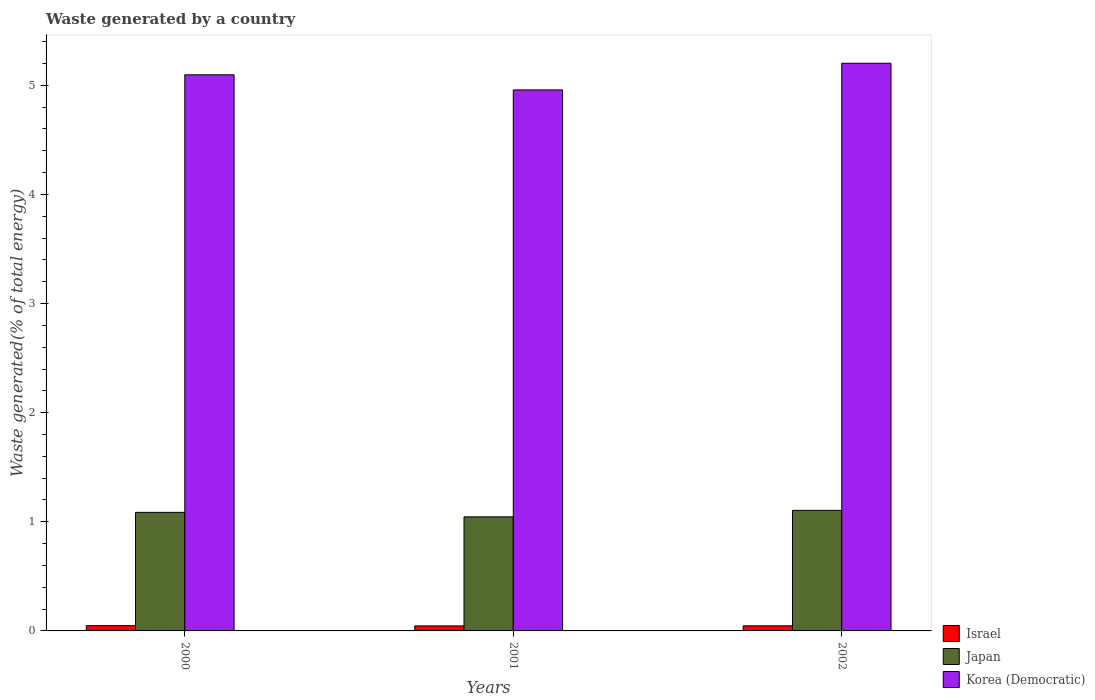How many different coloured bars are there?
Your answer should be very brief. 3. Are the number of bars per tick equal to the number of legend labels?
Keep it short and to the point. Yes. How many bars are there on the 1st tick from the left?
Your answer should be very brief. 3. What is the label of the 1st group of bars from the left?
Offer a very short reply. 2000. In how many cases, is the number of bars for a given year not equal to the number of legend labels?
Your answer should be compact. 0. What is the total waste generated in Israel in 2001?
Provide a short and direct response. 0.05. Across all years, what is the maximum total waste generated in Japan?
Give a very brief answer. 1.1. Across all years, what is the minimum total waste generated in Israel?
Keep it short and to the point. 0.05. In which year was the total waste generated in Israel maximum?
Ensure brevity in your answer.  2000. In which year was the total waste generated in Korea (Democratic) minimum?
Give a very brief answer. 2001. What is the total total waste generated in Korea (Democratic) in the graph?
Keep it short and to the point. 15.26. What is the difference between the total waste generated in Israel in 2001 and that in 2002?
Offer a very short reply. -0. What is the difference between the total waste generated in Japan in 2000 and the total waste generated in Korea (Democratic) in 2001?
Offer a terse response. -3.87. What is the average total waste generated in Korea (Democratic) per year?
Ensure brevity in your answer.  5.09. In the year 2000, what is the difference between the total waste generated in Japan and total waste generated in Israel?
Keep it short and to the point. 1.04. What is the ratio of the total waste generated in Korea (Democratic) in 2001 to that in 2002?
Provide a short and direct response. 0.95. Is the total waste generated in Israel in 2001 less than that in 2002?
Your response must be concise. Yes. Is the difference between the total waste generated in Japan in 2000 and 2001 greater than the difference between the total waste generated in Israel in 2000 and 2001?
Keep it short and to the point. Yes. What is the difference between the highest and the second highest total waste generated in Japan?
Make the answer very short. 0.02. What is the difference between the highest and the lowest total waste generated in Israel?
Your response must be concise. 0. In how many years, is the total waste generated in Japan greater than the average total waste generated in Japan taken over all years?
Offer a terse response. 2. Is the sum of the total waste generated in Korea (Democratic) in 2000 and 2001 greater than the maximum total waste generated in Japan across all years?
Make the answer very short. Yes. What does the 1st bar from the right in 2000 represents?
Your response must be concise. Korea (Democratic). Where does the legend appear in the graph?
Give a very brief answer. Bottom right. How are the legend labels stacked?
Make the answer very short. Vertical. What is the title of the graph?
Offer a terse response. Waste generated by a country. Does "Ireland" appear as one of the legend labels in the graph?
Keep it short and to the point. No. What is the label or title of the X-axis?
Keep it short and to the point. Years. What is the label or title of the Y-axis?
Make the answer very short. Waste generated(% of total energy). What is the Waste generated(% of total energy) in Israel in 2000?
Ensure brevity in your answer.  0.05. What is the Waste generated(% of total energy) in Japan in 2000?
Give a very brief answer. 1.09. What is the Waste generated(% of total energy) in Korea (Democratic) in 2000?
Provide a succinct answer. 5.1. What is the Waste generated(% of total energy) in Israel in 2001?
Provide a short and direct response. 0.05. What is the Waste generated(% of total energy) of Japan in 2001?
Give a very brief answer. 1.05. What is the Waste generated(% of total energy) in Korea (Democratic) in 2001?
Offer a terse response. 4.96. What is the Waste generated(% of total energy) of Israel in 2002?
Keep it short and to the point. 0.05. What is the Waste generated(% of total energy) of Japan in 2002?
Ensure brevity in your answer.  1.1. What is the Waste generated(% of total energy) in Korea (Democratic) in 2002?
Keep it short and to the point. 5.2. Across all years, what is the maximum Waste generated(% of total energy) in Israel?
Offer a terse response. 0.05. Across all years, what is the maximum Waste generated(% of total energy) of Japan?
Ensure brevity in your answer.  1.1. Across all years, what is the maximum Waste generated(% of total energy) of Korea (Democratic)?
Make the answer very short. 5.2. Across all years, what is the minimum Waste generated(% of total energy) of Israel?
Your answer should be compact. 0.05. Across all years, what is the minimum Waste generated(% of total energy) in Japan?
Your answer should be compact. 1.05. Across all years, what is the minimum Waste generated(% of total energy) in Korea (Democratic)?
Your answer should be very brief. 4.96. What is the total Waste generated(% of total energy) of Israel in the graph?
Provide a succinct answer. 0.14. What is the total Waste generated(% of total energy) of Japan in the graph?
Your answer should be very brief. 3.24. What is the total Waste generated(% of total energy) of Korea (Democratic) in the graph?
Your answer should be very brief. 15.26. What is the difference between the Waste generated(% of total energy) of Israel in 2000 and that in 2001?
Keep it short and to the point. 0. What is the difference between the Waste generated(% of total energy) in Japan in 2000 and that in 2001?
Provide a succinct answer. 0.04. What is the difference between the Waste generated(% of total energy) in Korea (Democratic) in 2000 and that in 2001?
Your response must be concise. 0.14. What is the difference between the Waste generated(% of total energy) of Israel in 2000 and that in 2002?
Your response must be concise. 0. What is the difference between the Waste generated(% of total energy) in Japan in 2000 and that in 2002?
Offer a very short reply. -0.02. What is the difference between the Waste generated(% of total energy) in Korea (Democratic) in 2000 and that in 2002?
Give a very brief answer. -0.11. What is the difference between the Waste generated(% of total energy) in Israel in 2001 and that in 2002?
Ensure brevity in your answer.  -0. What is the difference between the Waste generated(% of total energy) in Japan in 2001 and that in 2002?
Keep it short and to the point. -0.06. What is the difference between the Waste generated(% of total energy) in Korea (Democratic) in 2001 and that in 2002?
Your answer should be very brief. -0.24. What is the difference between the Waste generated(% of total energy) of Israel in 2000 and the Waste generated(% of total energy) of Japan in 2001?
Offer a very short reply. -1. What is the difference between the Waste generated(% of total energy) in Israel in 2000 and the Waste generated(% of total energy) in Korea (Democratic) in 2001?
Your response must be concise. -4.91. What is the difference between the Waste generated(% of total energy) in Japan in 2000 and the Waste generated(% of total energy) in Korea (Democratic) in 2001?
Your response must be concise. -3.87. What is the difference between the Waste generated(% of total energy) of Israel in 2000 and the Waste generated(% of total energy) of Japan in 2002?
Offer a very short reply. -1.06. What is the difference between the Waste generated(% of total energy) of Israel in 2000 and the Waste generated(% of total energy) of Korea (Democratic) in 2002?
Provide a short and direct response. -5.15. What is the difference between the Waste generated(% of total energy) in Japan in 2000 and the Waste generated(% of total energy) in Korea (Democratic) in 2002?
Keep it short and to the point. -4.12. What is the difference between the Waste generated(% of total energy) of Israel in 2001 and the Waste generated(% of total energy) of Japan in 2002?
Offer a very short reply. -1.06. What is the difference between the Waste generated(% of total energy) of Israel in 2001 and the Waste generated(% of total energy) of Korea (Democratic) in 2002?
Your response must be concise. -5.16. What is the difference between the Waste generated(% of total energy) of Japan in 2001 and the Waste generated(% of total energy) of Korea (Democratic) in 2002?
Your answer should be very brief. -4.16. What is the average Waste generated(% of total energy) of Israel per year?
Your response must be concise. 0.05. What is the average Waste generated(% of total energy) of Japan per year?
Give a very brief answer. 1.08. What is the average Waste generated(% of total energy) in Korea (Democratic) per year?
Provide a short and direct response. 5.09. In the year 2000, what is the difference between the Waste generated(% of total energy) in Israel and Waste generated(% of total energy) in Japan?
Offer a very short reply. -1.04. In the year 2000, what is the difference between the Waste generated(% of total energy) of Israel and Waste generated(% of total energy) of Korea (Democratic)?
Provide a succinct answer. -5.05. In the year 2000, what is the difference between the Waste generated(% of total energy) of Japan and Waste generated(% of total energy) of Korea (Democratic)?
Give a very brief answer. -4.01. In the year 2001, what is the difference between the Waste generated(% of total energy) of Israel and Waste generated(% of total energy) of Japan?
Keep it short and to the point. -1. In the year 2001, what is the difference between the Waste generated(% of total energy) of Israel and Waste generated(% of total energy) of Korea (Democratic)?
Ensure brevity in your answer.  -4.91. In the year 2001, what is the difference between the Waste generated(% of total energy) of Japan and Waste generated(% of total energy) of Korea (Democratic)?
Offer a terse response. -3.91. In the year 2002, what is the difference between the Waste generated(% of total energy) of Israel and Waste generated(% of total energy) of Japan?
Your answer should be very brief. -1.06. In the year 2002, what is the difference between the Waste generated(% of total energy) in Israel and Waste generated(% of total energy) in Korea (Democratic)?
Provide a succinct answer. -5.16. In the year 2002, what is the difference between the Waste generated(% of total energy) of Japan and Waste generated(% of total energy) of Korea (Democratic)?
Give a very brief answer. -4.1. What is the ratio of the Waste generated(% of total energy) in Israel in 2000 to that in 2001?
Ensure brevity in your answer.  1.05. What is the ratio of the Waste generated(% of total energy) in Japan in 2000 to that in 2001?
Your response must be concise. 1.04. What is the ratio of the Waste generated(% of total energy) in Korea (Democratic) in 2000 to that in 2001?
Offer a very short reply. 1.03. What is the ratio of the Waste generated(% of total energy) of Israel in 2000 to that in 2002?
Provide a short and direct response. 1.03. What is the ratio of the Waste generated(% of total energy) of Japan in 2000 to that in 2002?
Offer a terse response. 0.98. What is the ratio of the Waste generated(% of total energy) in Korea (Democratic) in 2000 to that in 2002?
Your answer should be compact. 0.98. What is the ratio of the Waste generated(% of total energy) in Israel in 2001 to that in 2002?
Your response must be concise. 0.98. What is the ratio of the Waste generated(% of total energy) in Japan in 2001 to that in 2002?
Keep it short and to the point. 0.95. What is the ratio of the Waste generated(% of total energy) in Korea (Democratic) in 2001 to that in 2002?
Ensure brevity in your answer.  0.95. What is the difference between the highest and the second highest Waste generated(% of total energy) in Israel?
Offer a terse response. 0. What is the difference between the highest and the second highest Waste generated(% of total energy) in Japan?
Keep it short and to the point. 0.02. What is the difference between the highest and the second highest Waste generated(% of total energy) in Korea (Democratic)?
Your answer should be compact. 0.11. What is the difference between the highest and the lowest Waste generated(% of total energy) in Israel?
Provide a short and direct response. 0. What is the difference between the highest and the lowest Waste generated(% of total energy) of Japan?
Ensure brevity in your answer.  0.06. What is the difference between the highest and the lowest Waste generated(% of total energy) of Korea (Democratic)?
Provide a succinct answer. 0.24. 